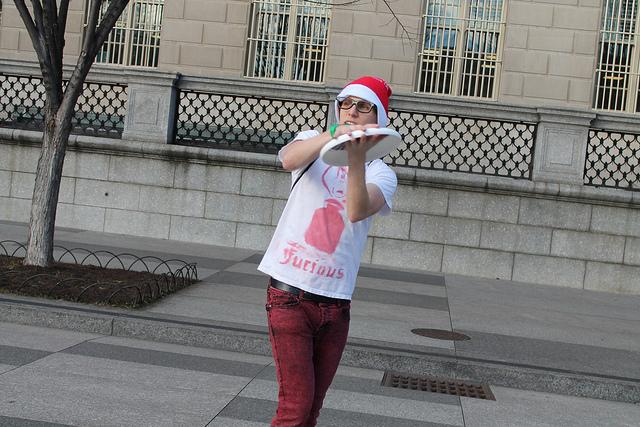What color are this person's pants?
Answer briefly. Red. Is there a tree in this picture?
Be succinct. Yes. What kind of hat is this person wearing?
Be succinct. Santa. 